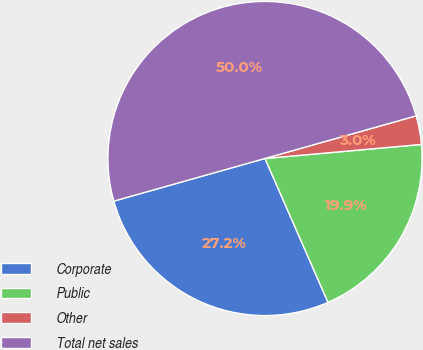<chart> <loc_0><loc_0><loc_500><loc_500><pie_chart><fcel>Corporate<fcel>Public<fcel>Other<fcel>Total net sales<nl><fcel>27.2%<fcel>19.85%<fcel>2.95%<fcel>50.0%<nl></chart> 